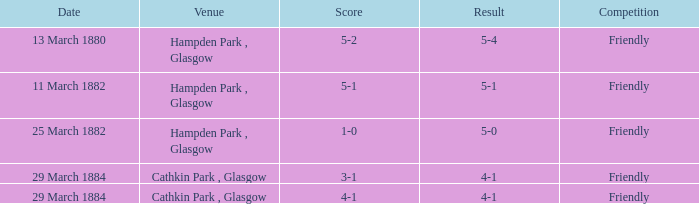Which competition had a 4-1 result, and a score of 4-1? Friendly. 